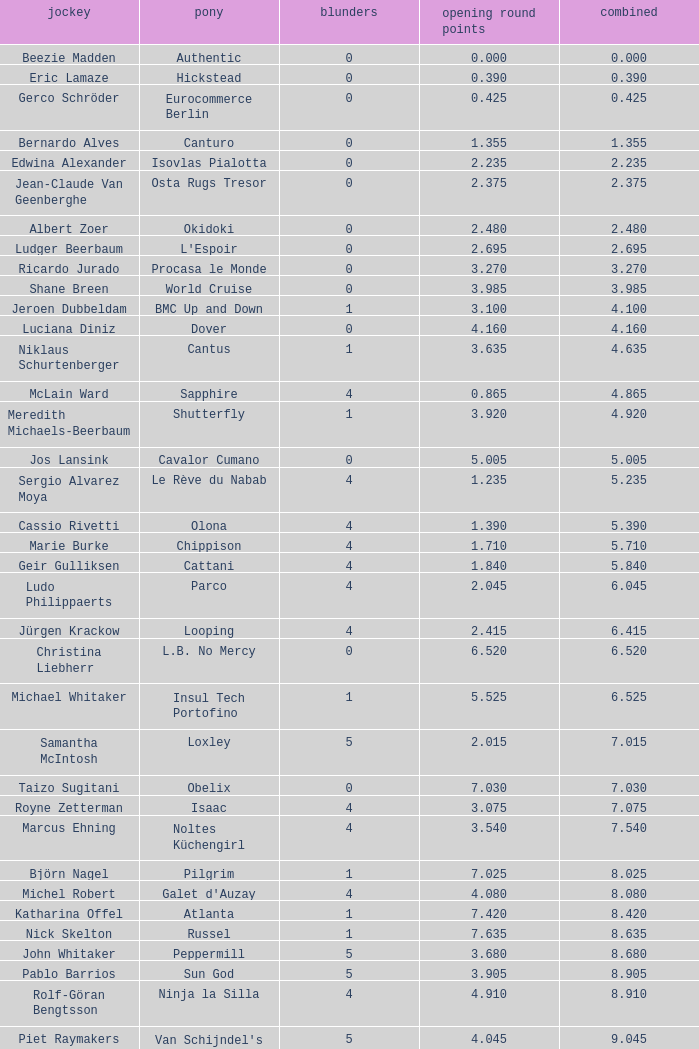Tell me the rider with 18.185 points round 1 Veronika Macanova. 